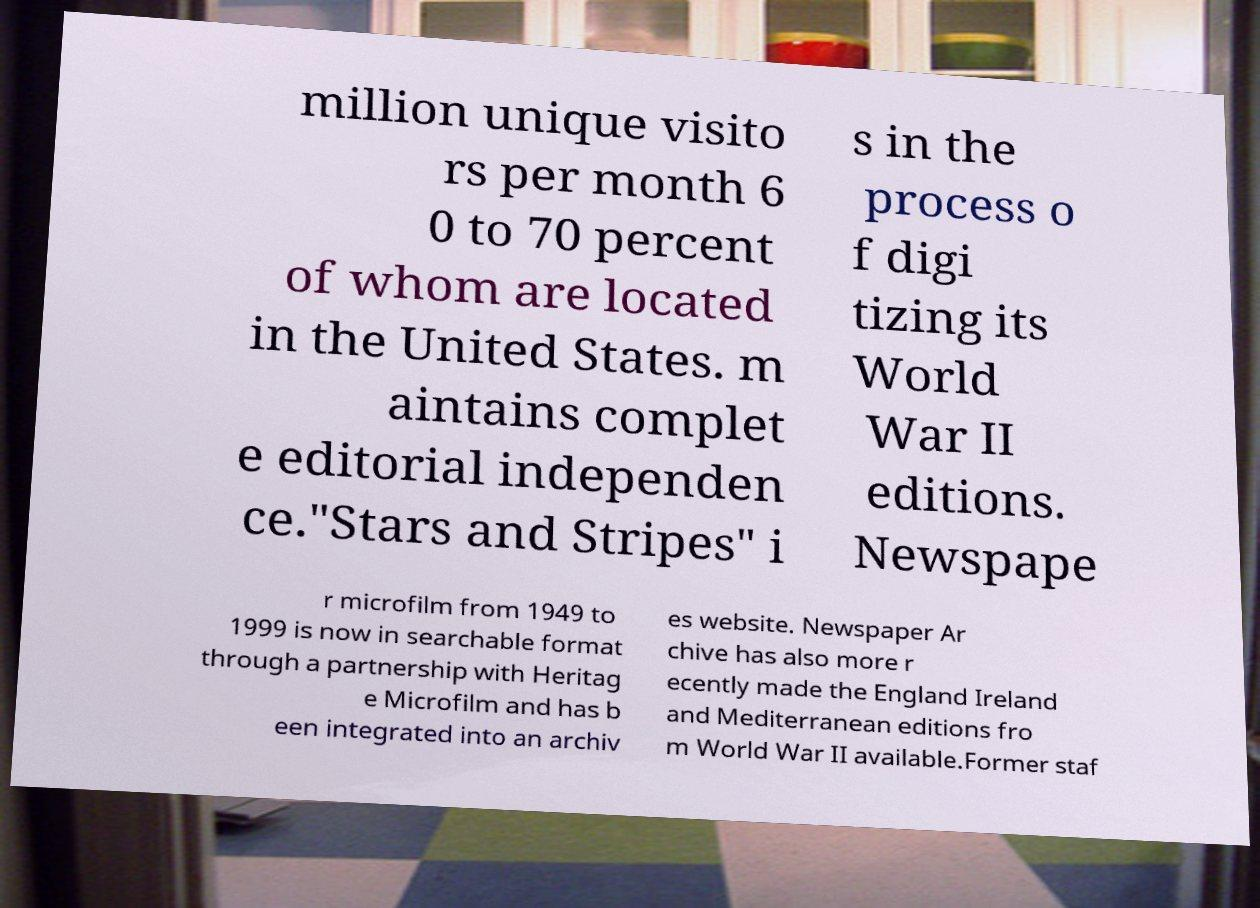There's text embedded in this image that I need extracted. Can you transcribe it verbatim? million unique visito rs per month 6 0 to 70 percent of whom are located in the United States. m aintains complet e editorial independen ce."Stars and Stripes" i s in the process o f digi tizing its World War II editions. Newspape r microfilm from 1949 to 1999 is now in searchable format through a partnership with Heritag e Microfilm and has b een integrated into an archiv es website. Newspaper Ar chive has also more r ecently made the England Ireland and Mediterranean editions fro m World War II available.Former staf 